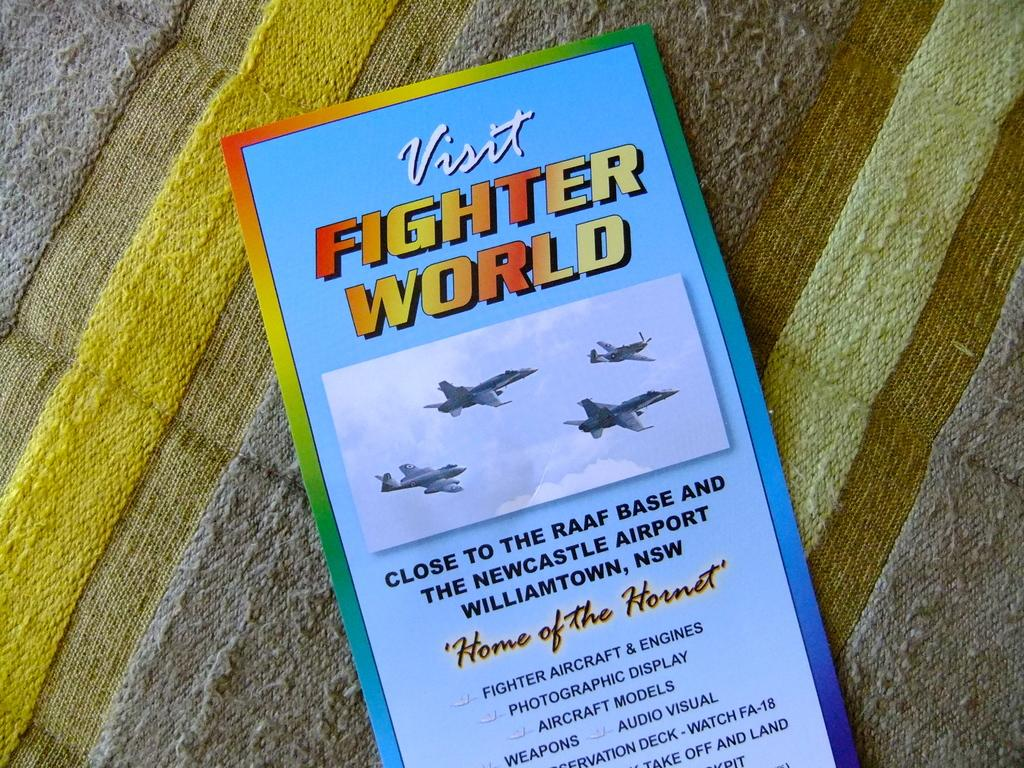<image>
Create a compact narrative representing the image presented. And attraction called Fighter World is the "Home of the Hornet". 